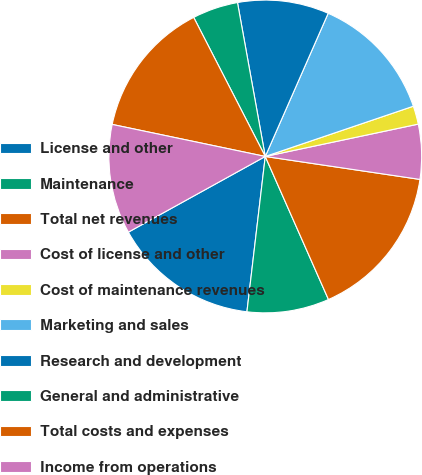<chart> <loc_0><loc_0><loc_500><loc_500><pie_chart><fcel>License and other<fcel>Maintenance<fcel>Total net revenues<fcel>Cost of license and other<fcel>Cost of maintenance revenues<fcel>Marketing and sales<fcel>Research and development<fcel>General and administrative<fcel>Total costs and expenses<fcel>Income from operations<nl><fcel>15.09%<fcel>8.49%<fcel>16.03%<fcel>5.66%<fcel>1.89%<fcel>13.2%<fcel>9.43%<fcel>4.72%<fcel>14.15%<fcel>11.32%<nl></chart> 